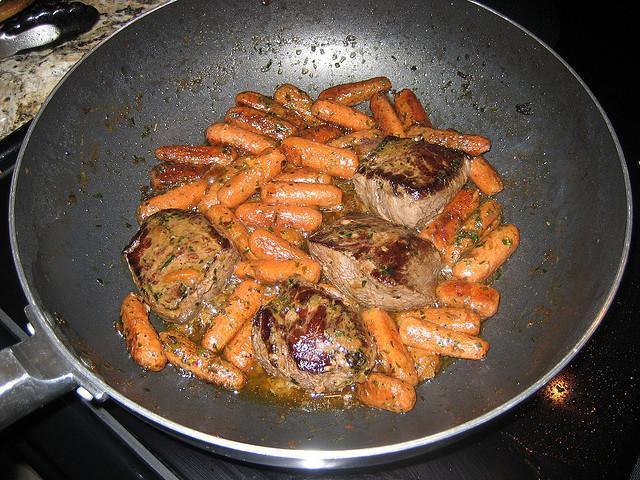How many elephants are there?
Give a very brief answer. 0. 